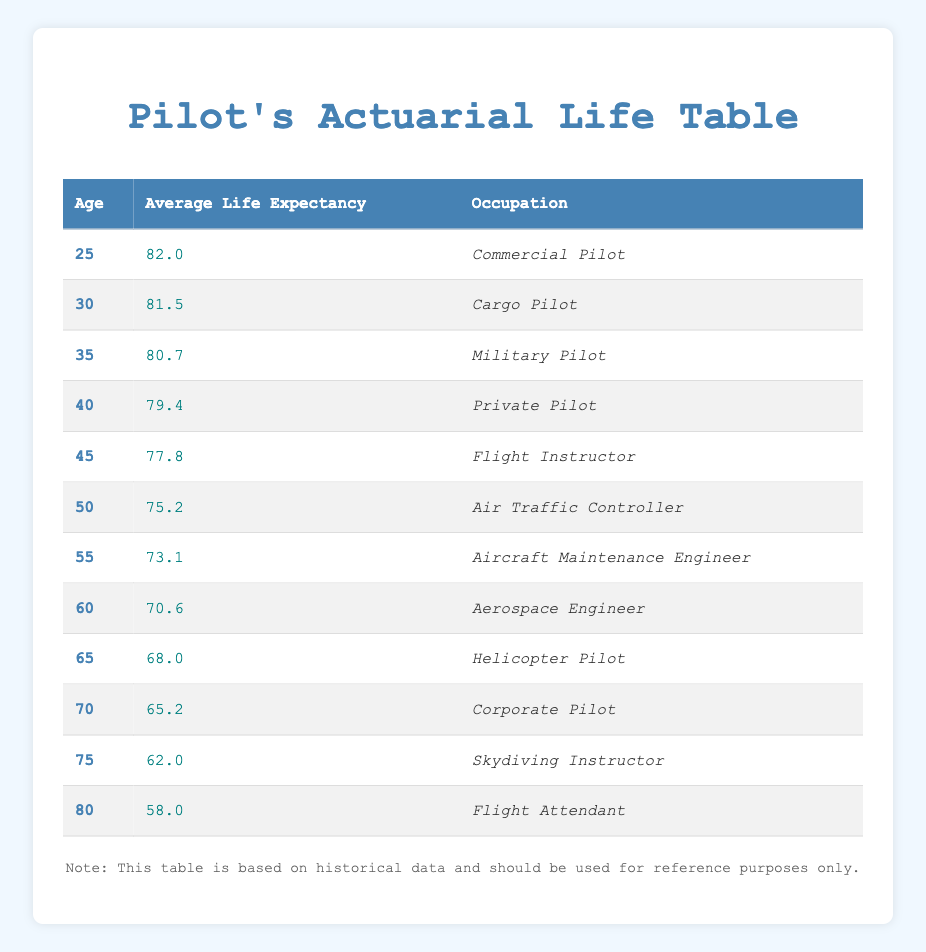What is the average life expectancy of a 50-year-old Commercial Pilot? The average life expectancy for a 50-year-old Commercial Pilot is found in the row corresponding to age 50 under the Average Life Expectancy column, which is 75.2.
Answer: 75.2 Which occupation has the lowest average life expectancy? The table shows that the Flight Attendant, at age 80, has the lowest average life expectancy of 58.0. It is the only entry for that age, making it straightforward to derive the answer.
Answer: Flight Attendant What is the average life expectancy difference between a 25-year-old and a 80-year-old Military Pilot? The average life expectancy for a 25-year-old is 82.0, while for an 80-year-old is not specified as Military Pilot, thus we ignore that. The age of 80 only shows life expectancy for Flight Attendant 58.0. Since there is no direct data for Military Pilot at age 80, we cannot compute a valid difference.
Answer: N/A Is the average life expectancy of an Aircraft Maintenance Engineer greater than 75 years? The average life expectancy for an Aircraft Maintenance Engineer at age 55 is 73.1 which is less than 75. Therefore, the statement is false.
Answer: No What is the average life expectancy of a Cargo Pilot compared to a Military Pilot at age 35? The average life expectancy for a Cargo Pilot at age 30 is 81.5, while for a Military Pilot at age 35 it is 80.7. Comparison shows that Cargo Pilots have a greater life expectancy than Military Pilots by subtracting the two values: 81.5 - 80.7 = 0.8.
Answer: Cargo Pilot has a higher expectancy by 0.8 